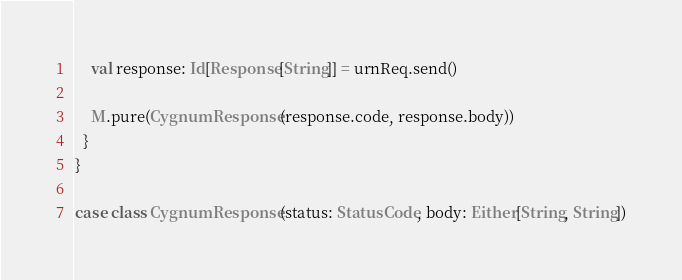Convert code to text. <code><loc_0><loc_0><loc_500><loc_500><_Scala_>    val response: Id[Response[String]] = urnReq.send()

    M.pure(CygnumResponse(response.code, response.body))
  }
}

case class CygnumResponse(status: StatusCode, body: Either[String, String])
</code> 